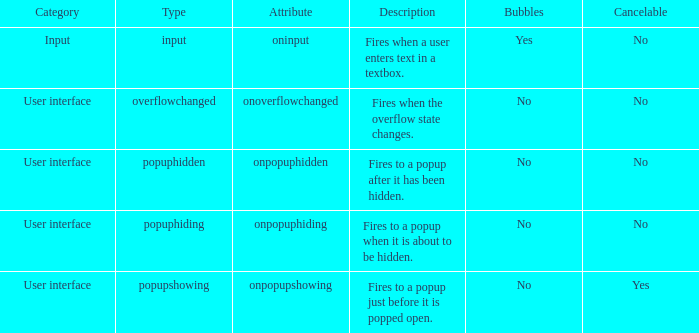How many bubbles with classification being input? 1.0. 